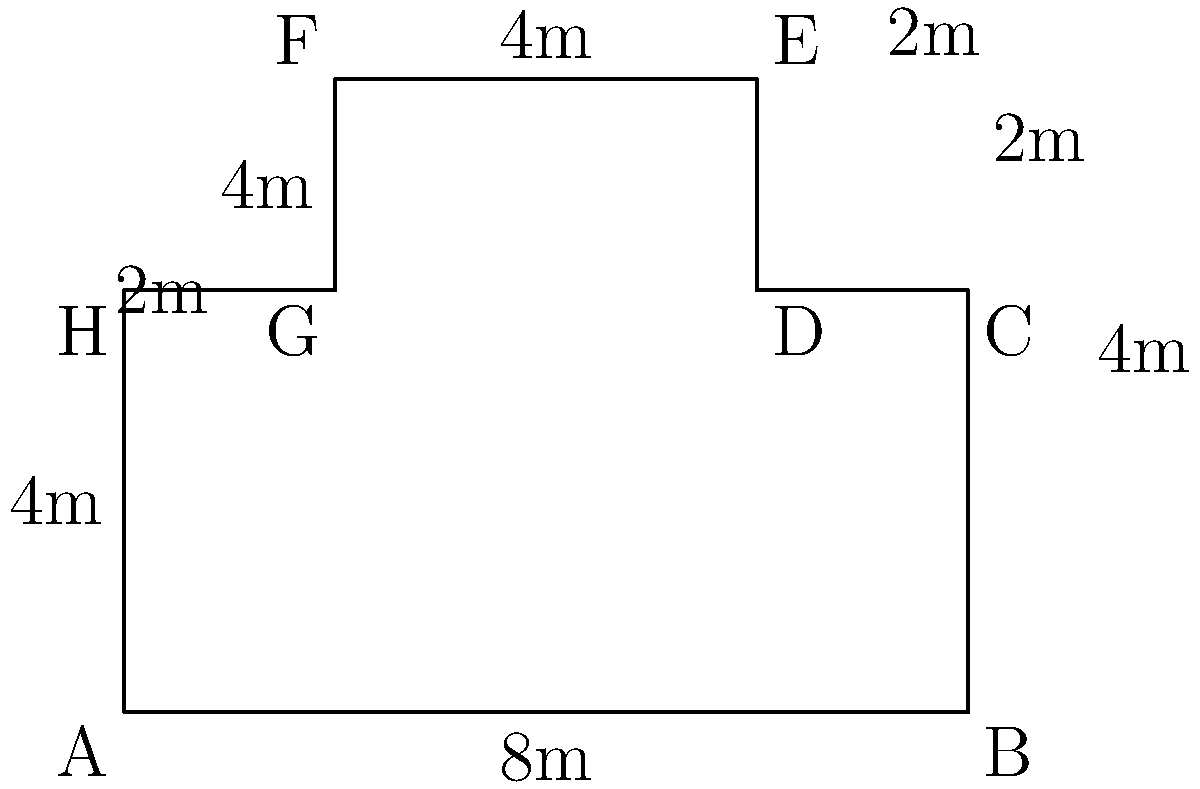At the upcoming American Idol finale in Portland, Oregon, you're tasked with calculating the perimeter of the irregularly shaped concert venue floor plan shown above. Each unit in the diagram represents 1 meter. What is the total perimeter of the venue in meters? Let's calculate the perimeter by adding up the lengths of all sides:

1. Bottom side (AB): 8m
2. Right side (BC): 4m
3. Right side (CD): 2m
4. Right side (DE): 2m
5. Top side (EF): 4m
6. Left side (FG): 4m
7. Left side (GH): 2m
8. Left side (HA): 4m

Now, let's add all these lengths:

$$8 + 4 + 2 + 2 + 4 + 4 + 2 + 4 = 30$$

Therefore, the total perimeter of the concert venue is 30 meters.
Answer: 30 meters 